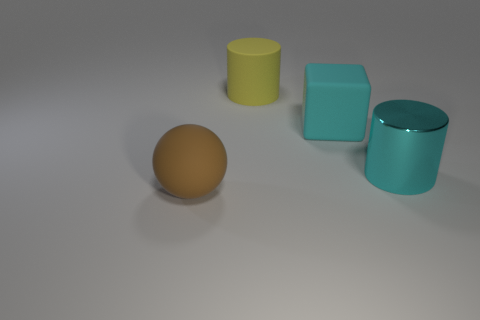Do the cube and the metal cylinder have the same color?
Ensure brevity in your answer.  Yes. There is a object right of the rubber cube; what size is it?
Provide a short and direct response. Large. What size is the brown thing?
Keep it short and to the point. Large. How many yellow matte cylinders are behind the big matte thing that is in front of the cyan metal thing on the right side of the cyan matte block?
Ensure brevity in your answer.  1. The big cylinder in front of the matte object that is behind the cyan cube is what color?
Provide a succinct answer. Cyan. How many other objects are there of the same material as the block?
Your answer should be very brief. 2. How many cyan metallic cylinders are right of the cyan thing that is behind the large shiny cylinder?
Provide a short and direct response. 1. Are there any other things that have the same shape as the large cyan rubber thing?
Keep it short and to the point. No. Do the cylinder right of the big matte cylinder and the matte object that is on the right side of the yellow matte thing have the same color?
Provide a short and direct response. Yes. Are there fewer large cylinders than large yellow rubber cylinders?
Offer a terse response. No. 